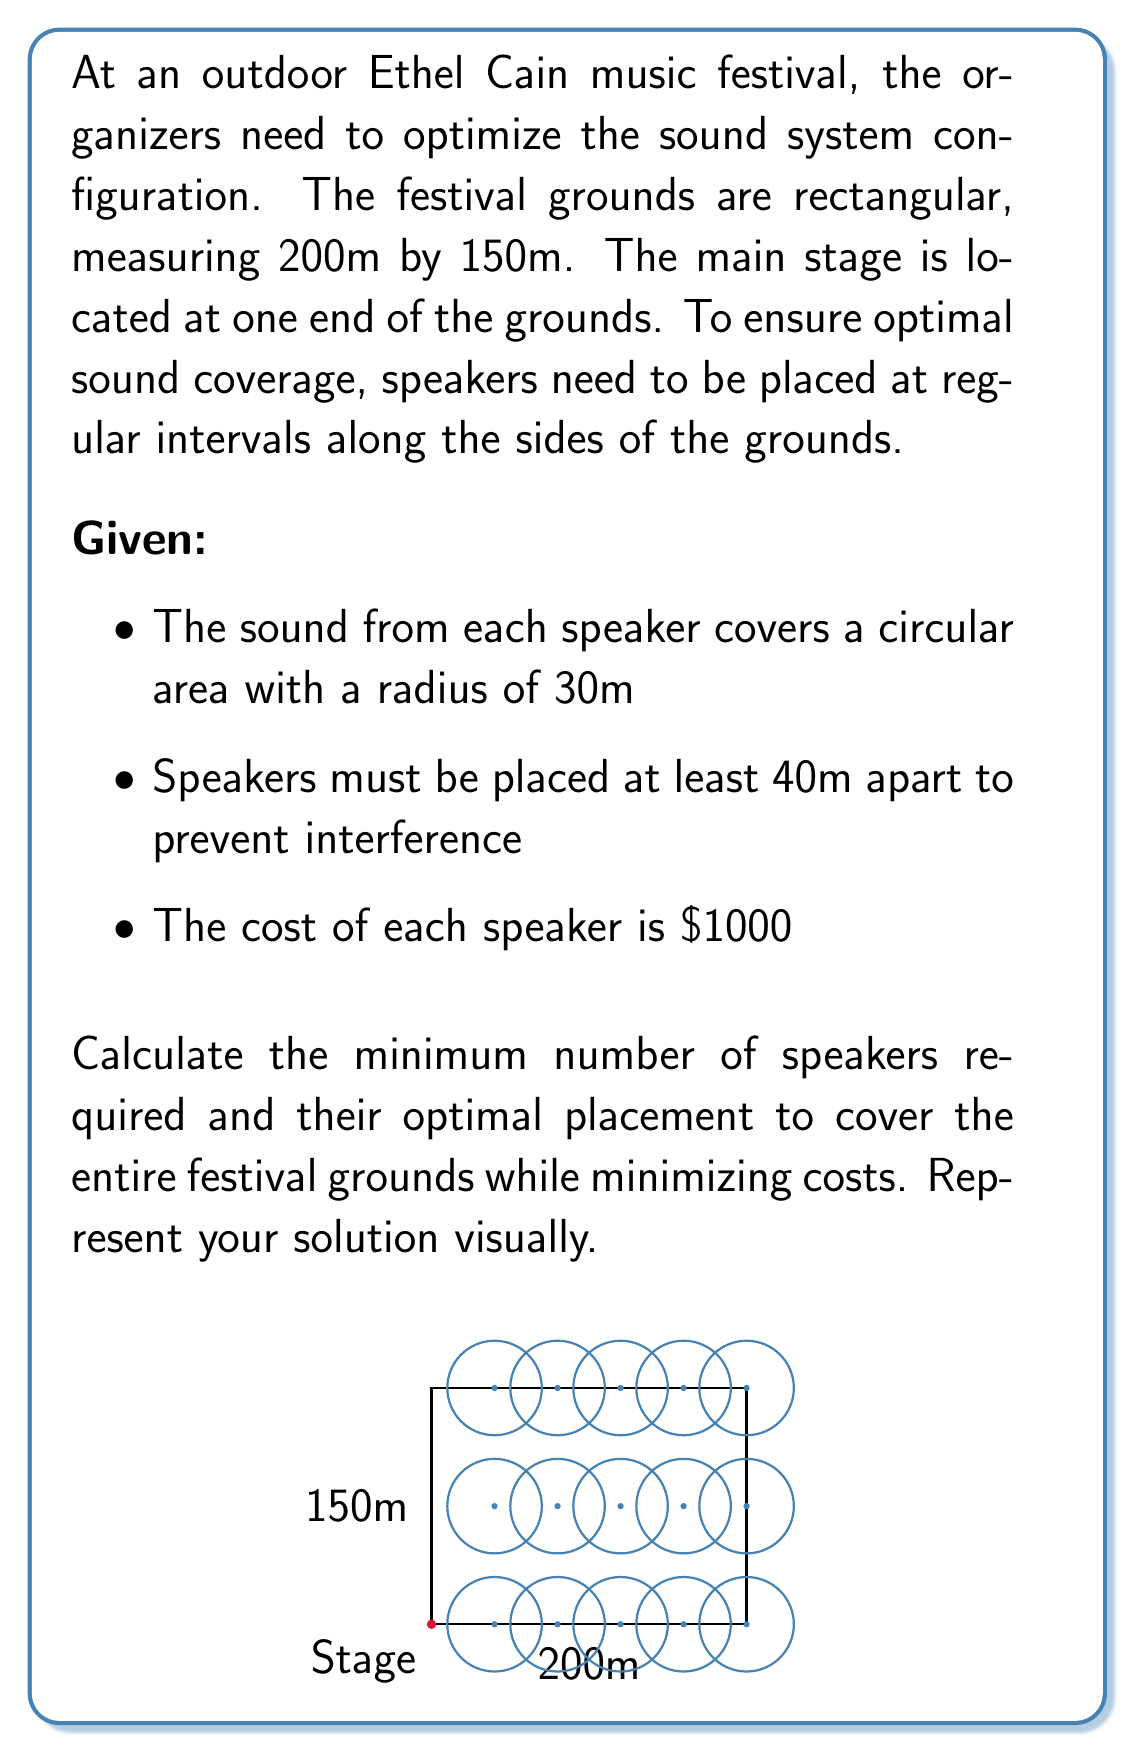Could you help me with this problem? Let's approach this step-by-step:

1) First, we need to determine the number of speakers required along the length and width of the grounds.

2) For the length (200m):
   - Speakers must be at least 40m apart
   - 200 ÷ 40 = 5 speakers (including one at each end)
   - This gives us 4 intervals of 50m each

3) For the width (150m):
   - 150 ÷ 40 = 3.75
   - We can fit 3 speakers with 2 intervals of 75m each

4) Now we have a grid of 5 x 3 = 15 speakers

5) Let's check if this covers the entire area:
   - Each speaker covers a circle with radius 30m
   - The diagonal of the rectangle formed by four adjacent speakers is:
     $$\sqrt{50^2 + 75^2} \approx 90.14m$$
   - The combined radius of two adjacent speakers is 60m
   - 60m < 90.14m, so there are some uncovered areas

6) To cover these gaps, we need to add speakers at the midpoints of the long sides:
   - This adds 2 more speakers

7) Total number of speakers: 15 + 2 = 17

8) Total cost: 17 * $1000 = $17,000

9) The optimal placement is shown in the diagram:
   - 5 speakers along each long side at 50m intervals
   - 3 speakers along each short side at 75m intervals
   - 1 additional speaker at the midpoint of each long side

This configuration ensures complete coverage of the festival grounds with the minimum number of speakers.
Answer: 17 speakers; $17,000 